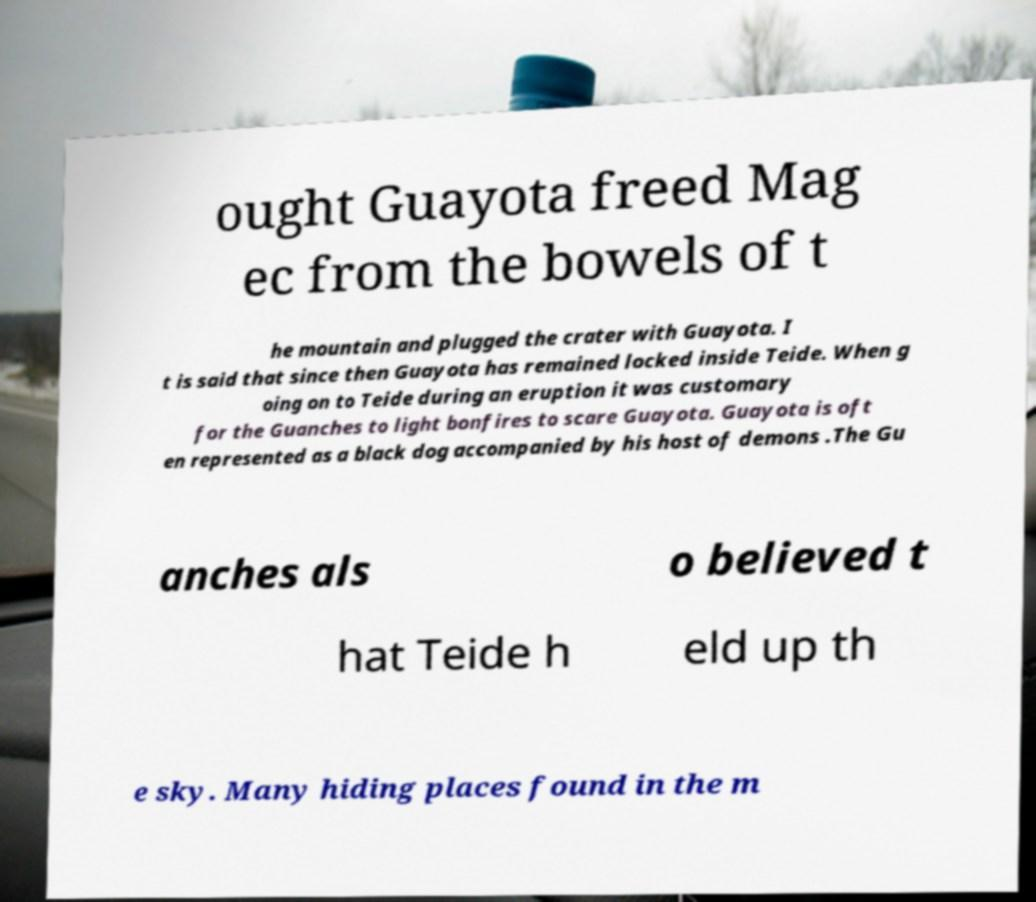Can you accurately transcribe the text from the provided image for me? ought Guayota freed Mag ec from the bowels of t he mountain and plugged the crater with Guayota. I t is said that since then Guayota has remained locked inside Teide. When g oing on to Teide during an eruption it was customary for the Guanches to light bonfires to scare Guayota. Guayota is oft en represented as a black dog accompanied by his host of demons .The Gu anches als o believed t hat Teide h eld up th e sky. Many hiding places found in the m 